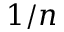<formula> <loc_0><loc_0><loc_500><loc_500>1 / n</formula> 